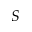<formula> <loc_0><loc_0><loc_500><loc_500>S</formula> 